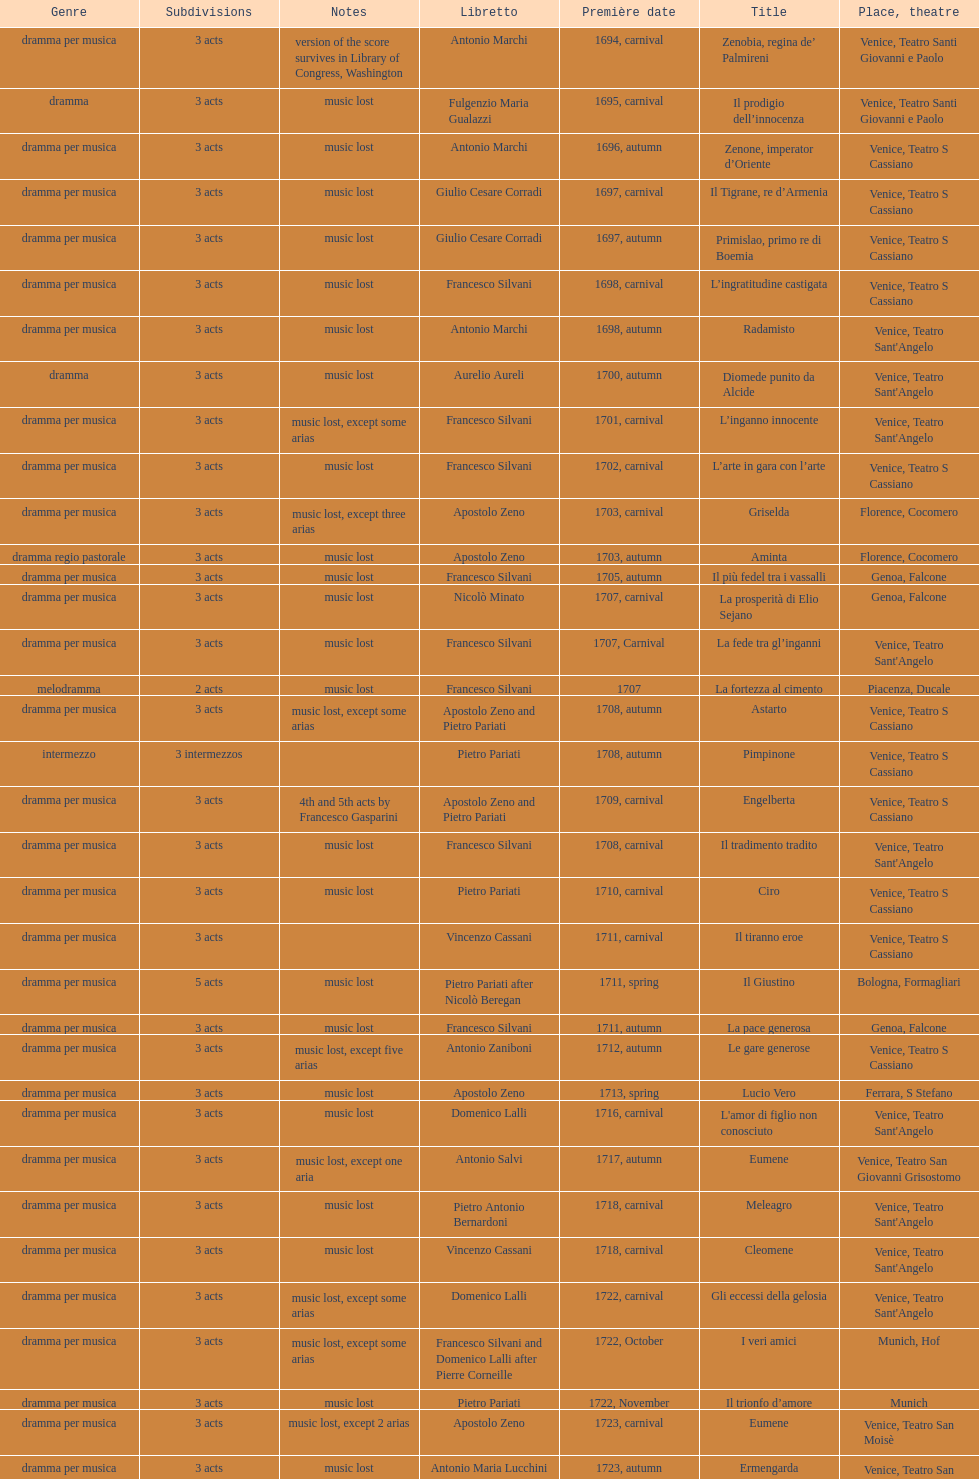How many were released after zenone, imperator d'oriente? 52. 